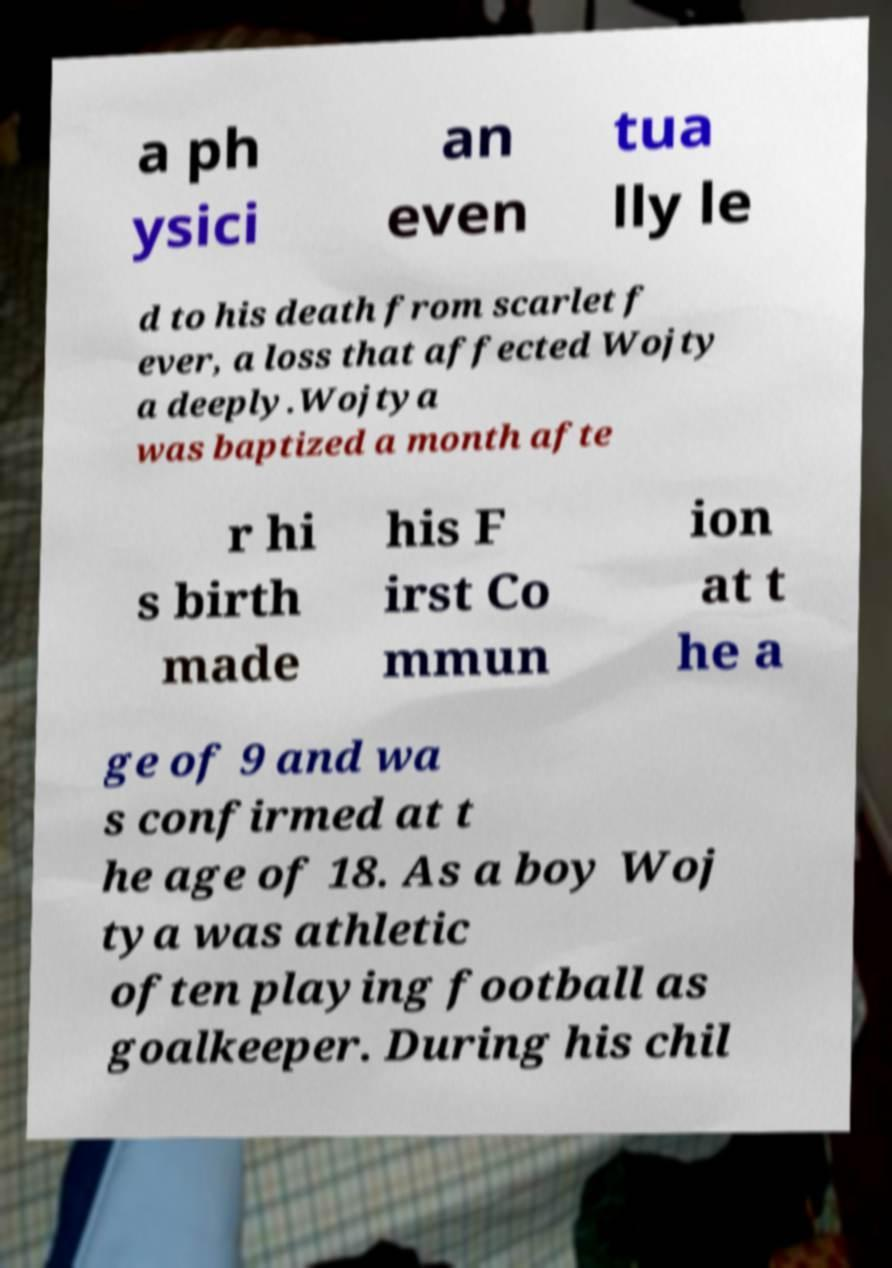Please identify and transcribe the text found in this image. a ph ysici an even tua lly le d to his death from scarlet f ever, a loss that affected Wojty a deeply.Wojtya was baptized a month afte r hi s birth made his F irst Co mmun ion at t he a ge of 9 and wa s confirmed at t he age of 18. As a boy Woj tya was athletic often playing football as goalkeeper. During his chil 